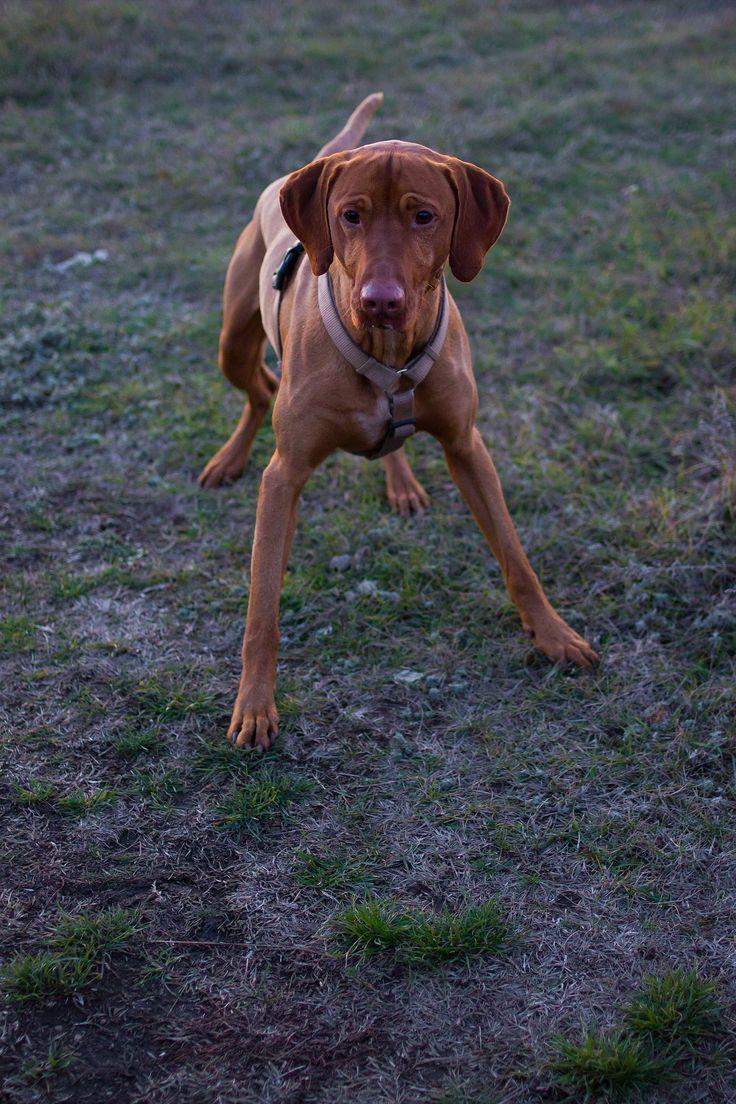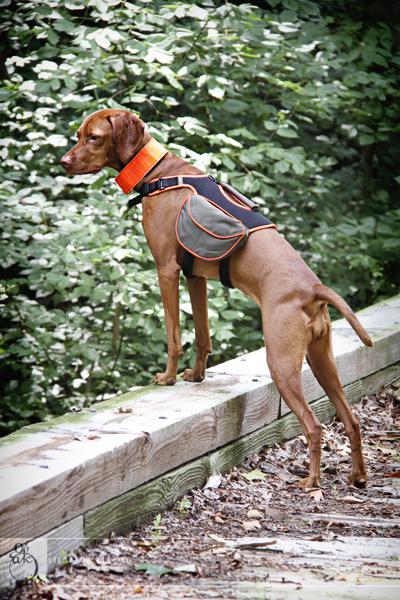The first image is the image on the left, the second image is the image on the right. Examine the images to the left and right. Is the description "In the right image, red-orange dogs are on each side of a man with a strap on his front." accurate? Answer yes or no. No. 